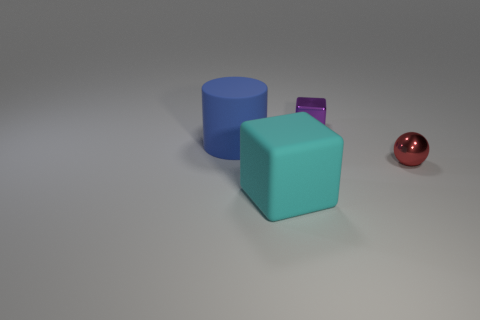Add 3 small shiny cubes. How many objects exist? 7 Subtract all cylinders. How many objects are left? 3 Add 3 tiny balls. How many tiny balls are left? 4 Add 1 red matte things. How many red matte things exist? 1 Subtract 0 purple spheres. How many objects are left? 4 Subtract all large rubber cubes. Subtract all large purple metal blocks. How many objects are left? 3 